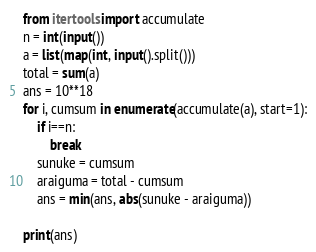<code> <loc_0><loc_0><loc_500><loc_500><_Python_>from itertools import accumulate
n = int(input())
a = list(map(int, input().split()))
total = sum(a)
ans = 10**18
for i, cumsum in enumerate(accumulate(a), start=1):
    if i==n:
        break
    sunuke = cumsum
    araiguma = total - cumsum
    ans = min(ans, abs(sunuke - araiguma))
    
print(ans)</code> 